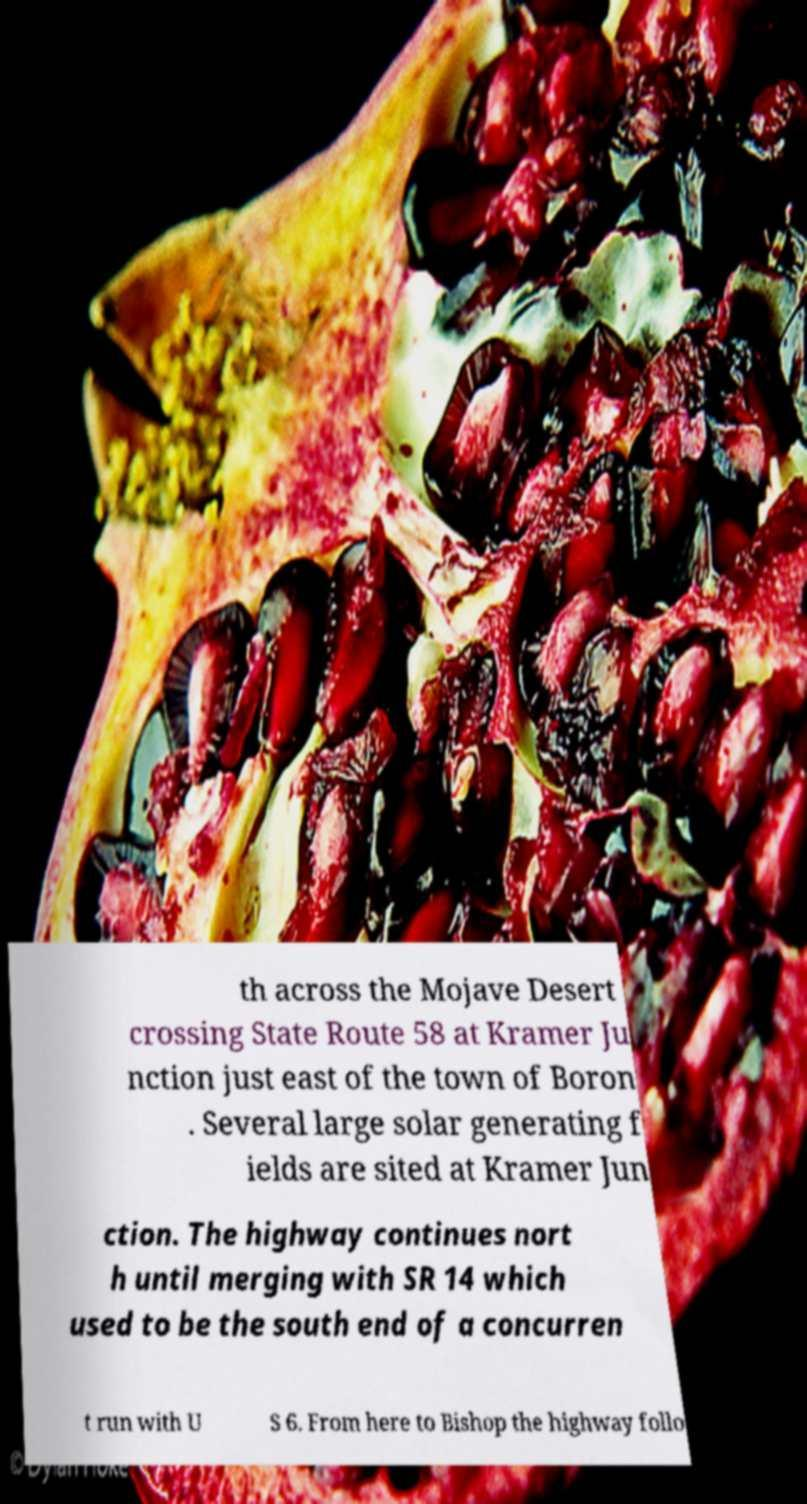Can you accurately transcribe the text from the provided image for me? th across the Mojave Desert crossing State Route 58 at Kramer Ju nction just east of the town of Boron . Several large solar generating f ields are sited at Kramer Jun ction. The highway continues nort h until merging with SR 14 which used to be the south end of a concurren t run with U S 6. From here to Bishop the highway follo 